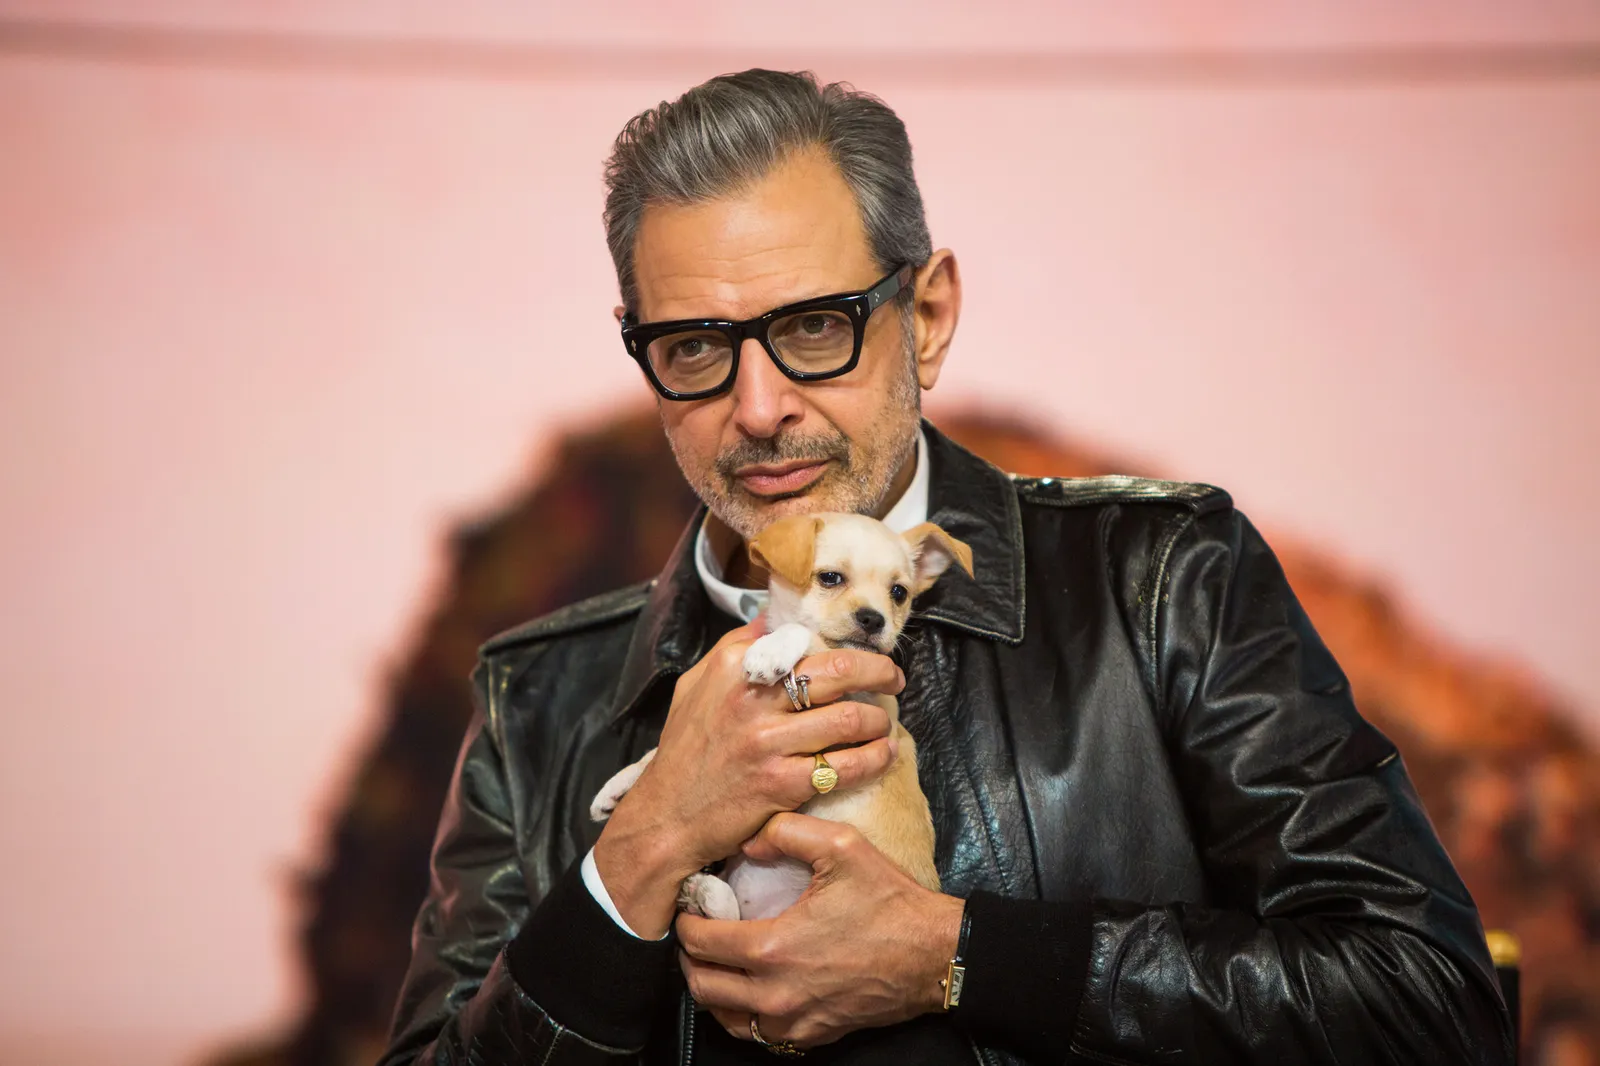Can you describe the emotional atmosphere of the image? The emotional atmosphere of the image is one of warmth and affection. The subject's gentle smile and the way he tenderly holds the small puppy convey a sense of calm and happiness. The vibrant pink backdrop adds a soft, warm glow to the scene, enhancing the feeling of joy and tenderness. The contrasting rugged rock formation to the right adds depth, making the image feel both intimate and grounded. What do you think the subject might be thinking in this moment? Given the content and context of the image, it seems likely that the subject is experiencing a moment of tranquility and contentment. His slight smile and the way he cradles the puppy suggest that he might be reflecting on the simple joys of companionship and the bond between humans and animals. It's a moment where external worries fade, leaving room for pure, unfiltered affection and appreciation for the present. Create a short story inspired by the image. Once in a bustling city, amidst the chaos and clamor, lived an actor whose life was a whirlwind of scenes and scripts. One serendipitous morning, he found a tiny, abandoned puppy nestled in the park. With eyes that mirrored the vast skies and a heart yearning for love, the puppy nuzzled into his arms. In that moment, the vibrant pink dawn cast its gentle light upon them as they stood beside a rugged rock. This newfound friendship, forged in the embrace of a new day, became a beacon of joy and serenity in their otherwise hectic lives. Each morning, they would return to the sharegpt4v/same spot, a reminder that even in the busiest of lives, there is always time for love and simple happiness. 